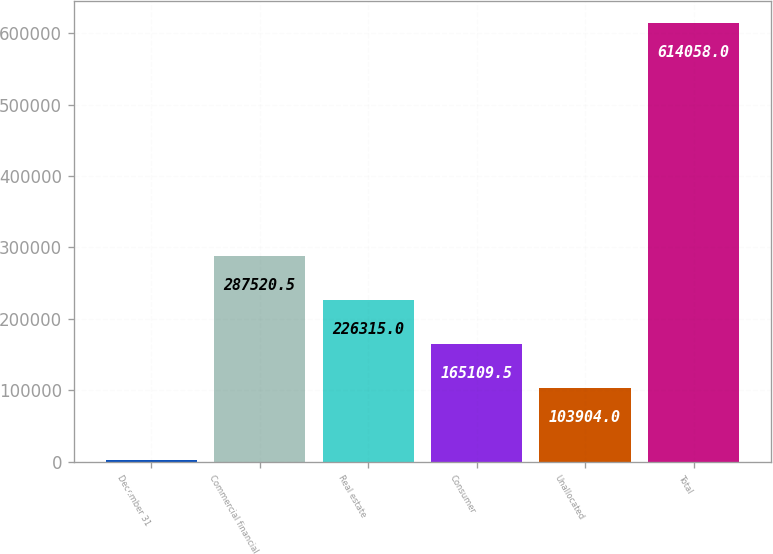Convert chart. <chart><loc_0><loc_0><loc_500><loc_500><bar_chart><fcel>December 31<fcel>Commercial financial<fcel>Real estate<fcel>Consumer<fcel>Unallocated<fcel>Total<nl><fcel>2003<fcel>287520<fcel>226315<fcel>165110<fcel>103904<fcel>614058<nl></chart> 